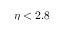<formula> <loc_0><loc_0><loc_500><loc_500>\eta < 2 . 8</formula> 